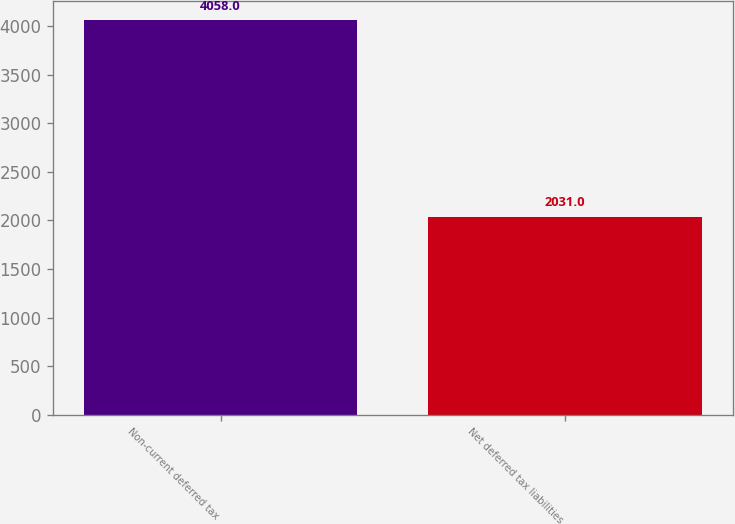Convert chart to OTSL. <chart><loc_0><loc_0><loc_500><loc_500><bar_chart><fcel>Non-current deferred tax<fcel>Net deferred tax liabilities<nl><fcel>4058<fcel>2031<nl></chart> 